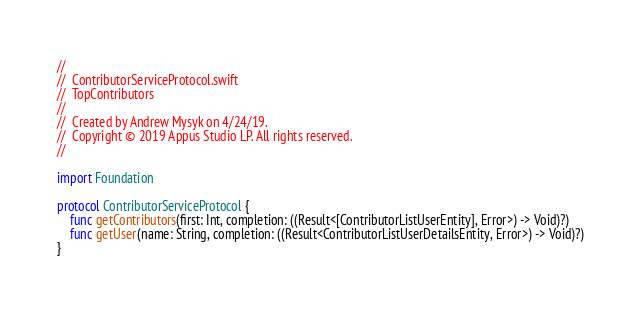<code> <loc_0><loc_0><loc_500><loc_500><_Swift_>//
//  ContributorServiceProtocol.swift
//  TopContributors
//
//  Created by Andrew Mysyk on 4/24/19.
//  Copyright © 2019 Appus Studio LP. All rights reserved.
//

import Foundation

protocol ContributorServiceProtocol {
    func getContributors(first: Int, completion: ((Result<[ContributorListUserEntity], Error>) -> Void)?)
    func getUser(name: String, completion: ((Result<ContributorListUserDetailsEntity, Error>) -> Void)?)
}
</code> 